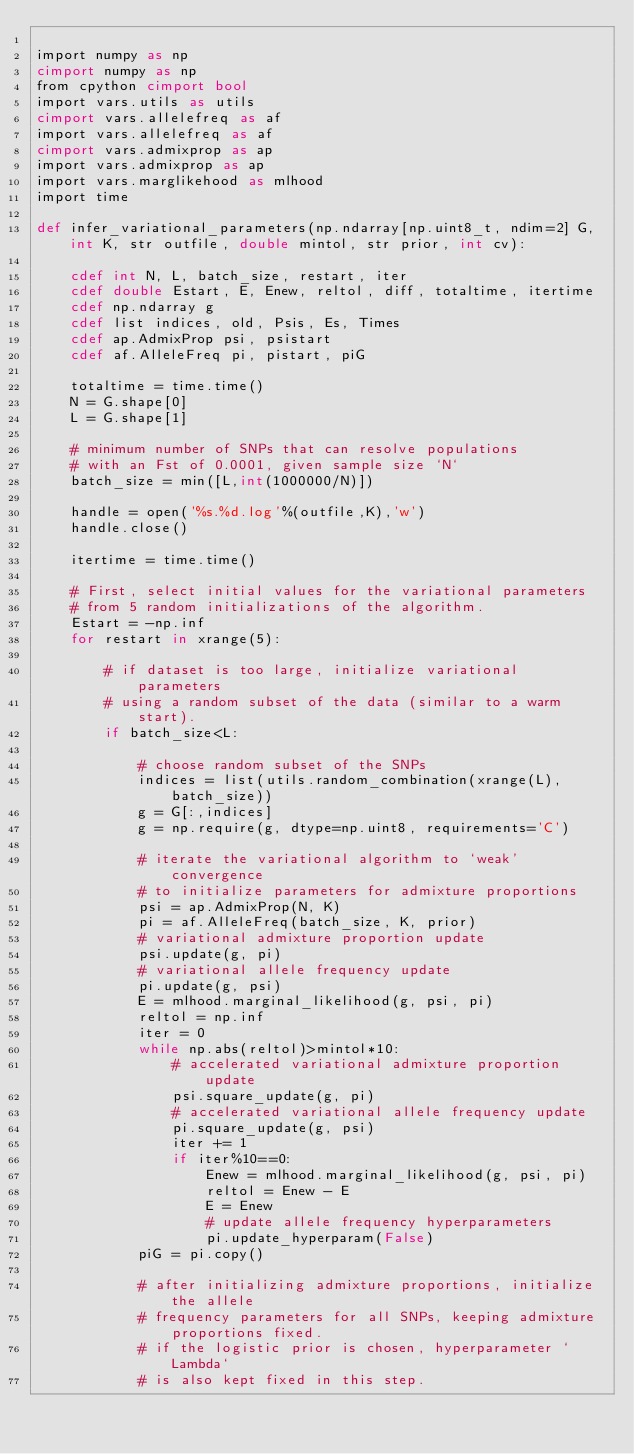Convert code to text. <code><loc_0><loc_0><loc_500><loc_500><_Cython_>
import numpy as np
cimport numpy as np
from cpython cimport bool
import vars.utils as utils
cimport vars.allelefreq as af 
import vars.allelefreq as af
cimport vars.admixprop as ap 
import vars.admixprop as ap
import vars.marglikehood as mlhood
import time

def infer_variational_parameters(np.ndarray[np.uint8_t, ndim=2] G, int K, str outfile, double mintol, str prior, int cv):

    cdef int N, L, batch_size, restart, iter
    cdef double Estart, E, Enew, reltol, diff, totaltime, itertime
    cdef np.ndarray g
    cdef list indices, old, Psis, Es, Times
    cdef ap.AdmixProp psi, psistart
    cdef af.AlleleFreq pi, pistart, piG

    totaltime = time.time()
    N = G.shape[0]
    L = G.shape[1]

    # minimum number of SNPs that can resolve populations
    # with an Fst of 0.0001, given sample size `N`
    batch_size = min([L,int(1000000/N)])

    handle = open('%s.%d.log'%(outfile,K),'w')
    handle.close()

    itertime = time.time()

    # First, select initial values for the variational parameters
    # from 5 random initializations of the algorithm.
    Estart = -np.inf
    for restart in xrange(5):

        # if dataset is too large, initialize variational parameters 
        # using a random subset of the data (similar to a warm start).
        if batch_size<L:

            # choose random subset of the SNPs
            indices = list(utils.random_combination(xrange(L), batch_size))
            g = G[:,indices]
            g = np.require(g, dtype=np.uint8, requirements='C')

            # iterate the variational algorithm to `weak' convergence
            # to initialize parameters for admixture proportions
            psi = ap.AdmixProp(N, K)
            pi = af.AlleleFreq(batch_size, K, prior)
            # variational admixture proportion update
            psi.update(g, pi)
            # variational allele frequency update
            pi.update(g, psi)
            E = mlhood.marginal_likelihood(g, psi, pi)
            reltol = np.inf
            iter = 0
            while np.abs(reltol)>mintol*10:
                # accelerated variational admixture proportion update
                psi.square_update(g, pi)
                # accelerated variational allele frequency update
                pi.square_update(g, psi)
                iter += 1
                if iter%10==0:
                    Enew = mlhood.marginal_likelihood(g, psi, pi)
                    reltol = Enew - E
                    E = Enew
                    # update allele frequency hyperparameters
                    pi.update_hyperparam(False)
            piG = pi.copy()

            # after initializing admixture proportions, initialize the allele
            # frequency parameters for all SNPs, keeping admixture proportions fixed.
            # if the logistic prior is chosen, hyperparameter `Lambda`
            # is also kept fixed in this step.</code> 